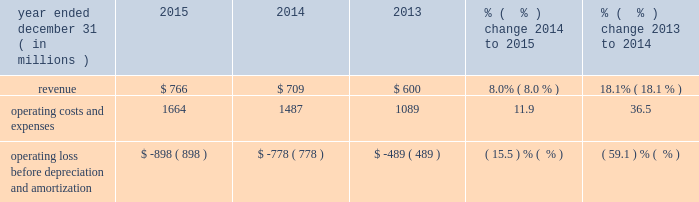Theme parks segment 2013 operating costs and expenses our theme parks segment operating costs and expenses consist primarily of theme park operations , includ- ing repairs and maintenance and related administrative expenses ; food , beverage and merchandise costs ; labor costs ; and sales and marketing costs .
Theme parks segment operating costs and expenses increased in 2015 and 2014 primarily due to additional costs at our orlando and hollywood theme parks associated with newer attractions , such as the fast fur- ious 2122 2014 supercharged 2122 studio tour in hollywood in 2015 and the wizarding world of harry potter 2122 2014 diagon alley 2122 in orlando in 2014 and increases in food , beverage and merchandise costs associated with the increases in attendance in both years .
Operating costs and expenses also increased in 2015 due to $ 89 million of operating costs and expenses attributable to universal studios japan and $ 22 million of transaction costs related to our development of a theme park in china .
Nbcuniversal headquarters , other and eliminations headquarters and other operating costs and expenses incurred by our nbcuniversal businesses include overhead , personnel costs and costs associated with corporate initiatives .
Operating costs and expenses increased in 2015 and 2014 primarily due to higher employee-related costs , including severance costs in corporate and other results of operations year ended december 31 ( in millions ) 2015 2014 2013 % (  % ) change 2014 to 2015 % (  % ) change 2013 to 2014 .
Corporate and other 2013 revenue other revenue primarily relates to comcast spectacor , which owns the philadelphia flyers and the wells fargo center arena in philadelphia , pennsylvania and operates arena management-related businesses .
Other revenue increased in 2015 and 2014 primarily due to increases in revenue from food and other services associated with new contracts entered into by one of our comcast spectacor businesses .
The increase in other revenue in 2014 was also due to an increase in revenue associated with newly acquired businesses .
Corporate and other 2013 operating costs and expenses corporate and other operating costs and expenses primarily include overhead , personnel costs , the costs of corporate initiatives and branding , and operating costs and expenses associated with comcast spectacor .
Excluding transaction costs associated with the time warner cable merger and related divestiture trans- actions of $ 178 million and $ 237 million in 2015 and 2014 , respectively , corporate and other operating costs and expenses increased 19% ( 19 % ) in 2015 .
This was primarily due to $ 56 million of expenses related to a contract settlement , an increase in expenses related to corporate strategic business initiatives and an increase in operating costs and expenses at comcast spectacor primarily associated with new contracts entered into by one of its businesses .
Corporate and other operating costs and expenses increased in 2014 primarily due to $ 237 million of transaction-related costs associated with the time warner cable merger and related divest- iture transactions , as well as an increase in operating costs and expenses associated with new contracts entered into by one of our comcast spectacor businesses .
Comcast 2015 annual report on form 10-k 60 .
What was the average revenues from 2013 to 2015? 
Computations: ((600 + (766 + 709)) / 3)
Answer: 691.66667. 